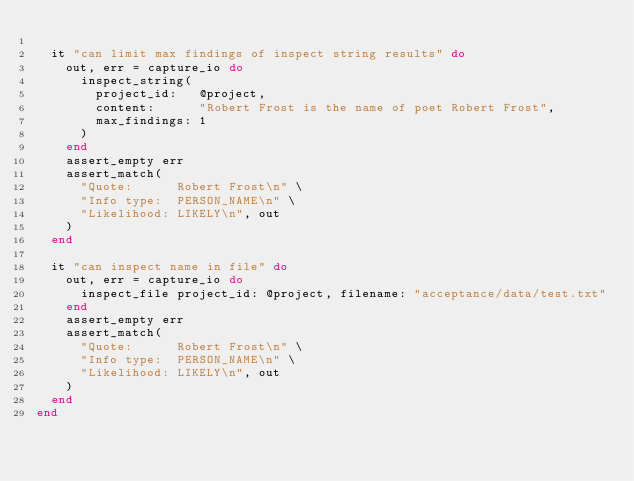Convert code to text. <code><loc_0><loc_0><loc_500><loc_500><_Ruby_>
  it "can limit max findings of inspect string results" do
    out, err = capture_io do
      inspect_string(
        project_id:   @project,
        content:      "Robert Frost is the name of poet Robert Frost",
        max_findings: 1
      )
    end
    assert_empty err
    assert_match(
      "Quote:      Robert Frost\n" \
      "Info type:  PERSON_NAME\n" \
      "Likelihood: LIKELY\n", out
    )
  end

  it "can inspect name in file" do
    out, err = capture_io do
      inspect_file project_id: @project, filename: "acceptance/data/test.txt"
    end
    assert_empty err
    assert_match(
      "Quote:      Robert Frost\n" \
      "Info type:  PERSON_NAME\n" \
      "Likelihood: LIKELY\n", out
    )
  end
end
</code> 